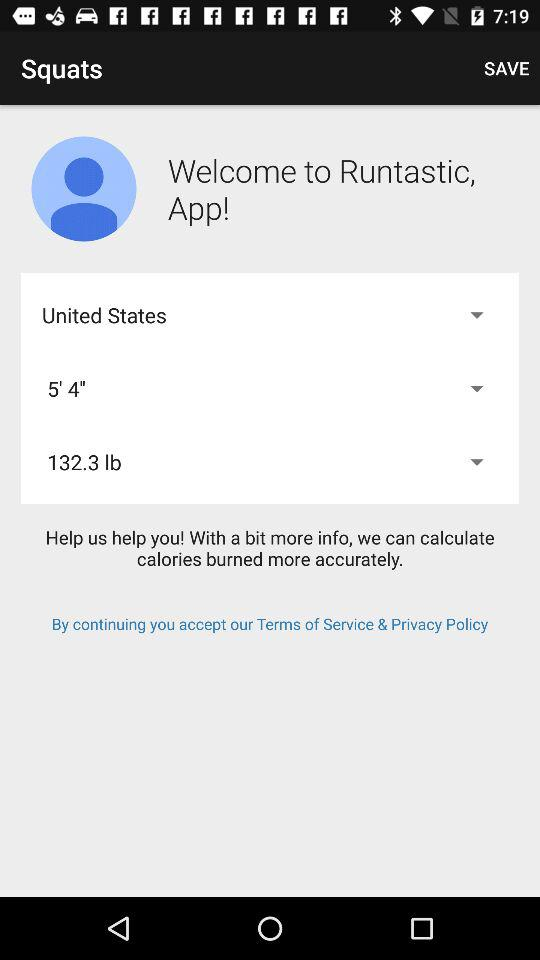What is the height? The height is five feet four inches. 